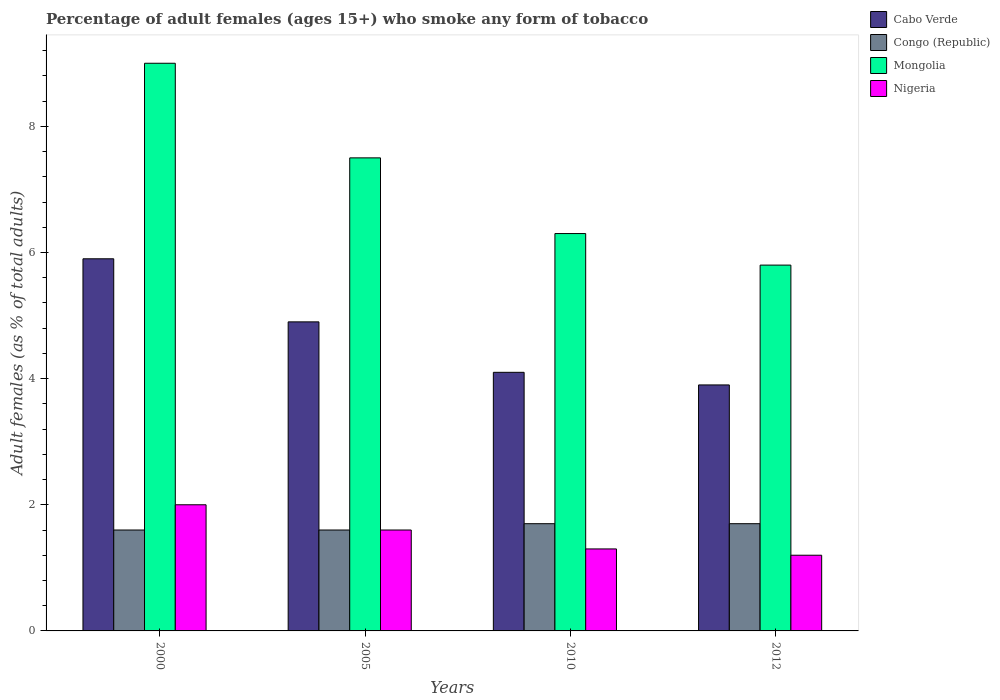How many different coloured bars are there?
Your answer should be very brief. 4. Are the number of bars per tick equal to the number of legend labels?
Your answer should be very brief. Yes. Are the number of bars on each tick of the X-axis equal?
Give a very brief answer. Yes. How many bars are there on the 4th tick from the right?
Offer a very short reply. 4. In how many cases, is the number of bars for a given year not equal to the number of legend labels?
Give a very brief answer. 0. Across all years, what is the maximum percentage of adult females who smoke in Cabo Verde?
Your answer should be very brief. 5.9. In which year was the percentage of adult females who smoke in Cabo Verde maximum?
Offer a very short reply. 2000. In which year was the percentage of adult females who smoke in Mongolia minimum?
Keep it short and to the point. 2012. What is the total percentage of adult females who smoke in Cabo Verde in the graph?
Give a very brief answer. 18.8. What is the difference between the percentage of adult females who smoke in Nigeria in 2005 and that in 2012?
Your response must be concise. 0.4. What is the difference between the percentage of adult females who smoke in Nigeria in 2005 and the percentage of adult females who smoke in Congo (Republic) in 2012?
Your answer should be compact. -0.1. What is the average percentage of adult females who smoke in Mongolia per year?
Ensure brevity in your answer.  7.15. In the year 2005, what is the difference between the percentage of adult females who smoke in Cabo Verde and percentage of adult females who smoke in Congo (Republic)?
Your answer should be compact. 3.3. In how many years, is the percentage of adult females who smoke in Nigeria greater than 4.4 %?
Give a very brief answer. 0. What is the ratio of the percentage of adult females who smoke in Cabo Verde in 2000 to that in 2012?
Offer a very short reply. 1.51. Is the difference between the percentage of adult females who smoke in Cabo Verde in 2000 and 2010 greater than the difference between the percentage of adult females who smoke in Congo (Republic) in 2000 and 2010?
Your answer should be compact. Yes. What is the difference between the highest and the second highest percentage of adult females who smoke in Nigeria?
Offer a very short reply. 0.4. In how many years, is the percentage of adult females who smoke in Nigeria greater than the average percentage of adult females who smoke in Nigeria taken over all years?
Provide a succinct answer. 2. Is the sum of the percentage of adult females who smoke in Cabo Verde in 2010 and 2012 greater than the maximum percentage of adult females who smoke in Congo (Republic) across all years?
Offer a terse response. Yes. Is it the case that in every year, the sum of the percentage of adult females who smoke in Nigeria and percentage of adult females who smoke in Mongolia is greater than the sum of percentage of adult females who smoke in Cabo Verde and percentage of adult females who smoke in Congo (Republic)?
Offer a very short reply. Yes. What does the 1st bar from the left in 2005 represents?
Make the answer very short. Cabo Verde. What does the 1st bar from the right in 2000 represents?
Ensure brevity in your answer.  Nigeria. Is it the case that in every year, the sum of the percentage of adult females who smoke in Cabo Verde and percentage of adult females who smoke in Nigeria is greater than the percentage of adult females who smoke in Congo (Republic)?
Ensure brevity in your answer.  Yes. Are all the bars in the graph horizontal?
Make the answer very short. No. What is the difference between two consecutive major ticks on the Y-axis?
Ensure brevity in your answer.  2. Are the values on the major ticks of Y-axis written in scientific E-notation?
Make the answer very short. No. Does the graph contain any zero values?
Your answer should be compact. No. Does the graph contain grids?
Offer a terse response. No. How are the legend labels stacked?
Offer a very short reply. Vertical. What is the title of the graph?
Ensure brevity in your answer.  Percentage of adult females (ages 15+) who smoke any form of tobacco. What is the label or title of the Y-axis?
Provide a succinct answer. Adult females (as % of total adults). What is the Adult females (as % of total adults) of Congo (Republic) in 2000?
Make the answer very short. 1.6. What is the Adult females (as % of total adults) in Mongolia in 2000?
Offer a very short reply. 9. What is the Adult females (as % of total adults) in Nigeria in 2000?
Offer a very short reply. 2. What is the Adult females (as % of total adults) in Mongolia in 2005?
Your answer should be compact. 7.5. What is the Adult females (as % of total adults) of Mongolia in 2010?
Offer a terse response. 6.3. What is the Adult females (as % of total adults) in Cabo Verde in 2012?
Provide a short and direct response. 3.9. What is the Adult females (as % of total adults) in Mongolia in 2012?
Offer a very short reply. 5.8. Across all years, what is the maximum Adult females (as % of total adults) in Congo (Republic)?
Keep it short and to the point. 1.7. Across all years, what is the maximum Adult females (as % of total adults) in Nigeria?
Provide a succinct answer. 2. Across all years, what is the minimum Adult females (as % of total adults) of Cabo Verde?
Make the answer very short. 3.9. Across all years, what is the minimum Adult females (as % of total adults) in Mongolia?
Your answer should be compact. 5.8. What is the total Adult females (as % of total adults) in Mongolia in the graph?
Your answer should be compact. 28.6. What is the total Adult females (as % of total adults) of Nigeria in the graph?
Provide a short and direct response. 6.1. What is the difference between the Adult females (as % of total adults) of Cabo Verde in 2000 and that in 2005?
Make the answer very short. 1. What is the difference between the Adult females (as % of total adults) of Congo (Republic) in 2000 and that in 2005?
Your answer should be compact. 0. What is the difference between the Adult females (as % of total adults) in Cabo Verde in 2000 and that in 2010?
Give a very brief answer. 1.8. What is the difference between the Adult females (as % of total adults) of Congo (Republic) in 2000 and that in 2010?
Ensure brevity in your answer.  -0.1. What is the difference between the Adult females (as % of total adults) of Mongolia in 2000 and that in 2010?
Provide a succinct answer. 2.7. What is the difference between the Adult females (as % of total adults) in Nigeria in 2000 and that in 2010?
Offer a terse response. 0.7. What is the difference between the Adult females (as % of total adults) in Congo (Republic) in 2000 and that in 2012?
Offer a very short reply. -0.1. What is the difference between the Adult females (as % of total adults) of Nigeria in 2000 and that in 2012?
Keep it short and to the point. 0.8. What is the difference between the Adult females (as % of total adults) of Cabo Verde in 2005 and that in 2010?
Give a very brief answer. 0.8. What is the difference between the Adult females (as % of total adults) in Nigeria in 2005 and that in 2010?
Provide a succinct answer. 0.3. What is the difference between the Adult females (as % of total adults) of Cabo Verde in 2005 and that in 2012?
Offer a very short reply. 1. What is the difference between the Adult females (as % of total adults) in Cabo Verde in 2010 and that in 2012?
Offer a very short reply. 0.2. What is the difference between the Adult females (as % of total adults) in Congo (Republic) in 2010 and that in 2012?
Ensure brevity in your answer.  0. What is the difference between the Adult females (as % of total adults) in Cabo Verde in 2000 and the Adult females (as % of total adults) in Congo (Republic) in 2005?
Offer a terse response. 4.3. What is the difference between the Adult females (as % of total adults) in Cabo Verde in 2000 and the Adult females (as % of total adults) in Nigeria in 2005?
Provide a succinct answer. 4.3. What is the difference between the Adult females (as % of total adults) of Congo (Republic) in 2000 and the Adult females (as % of total adults) of Mongolia in 2005?
Provide a short and direct response. -5.9. What is the difference between the Adult females (as % of total adults) in Mongolia in 2000 and the Adult females (as % of total adults) in Nigeria in 2005?
Your answer should be very brief. 7.4. What is the difference between the Adult females (as % of total adults) in Cabo Verde in 2000 and the Adult females (as % of total adults) in Congo (Republic) in 2010?
Keep it short and to the point. 4.2. What is the difference between the Adult females (as % of total adults) of Congo (Republic) in 2000 and the Adult females (as % of total adults) of Mongolia in 2010?
Keep it short and to the point. -4.7. What is the difference between the Adult females (as % of total adults) of Cabo Verde in 2000 and the Adult females (as % of total adults) of Nigeria in 2012?
Provide a succinct answer. 4.7. What is the difference between the Adult females (as % of total adults) in Mongolia in 2000 and the Adult females (as % of total adults) in Nigeria in 2012?
Give a very brief answer. 7.8. What is the difference between the Adult females (as % of total adults) in Cabo Verde in 2005 and the Adult females (as % of total adults) in Nigeria in 2010?
Your answer should be compact. 3.6. What is the difference between the Adult females (as % of total adults) in Mongolia in 2005 and the Adult females (as % of total adults) in Nigeria in 2010?
Give a very brief answer. 6.2. What is the difference between the Adult females (as % of total adults) in Cabo Verde in 2005 and the Adult females (as % of total adults) in Congo (Republic) in 2012?
Keep it short and to the point. 3.2. What is the difference between the Adult females (as % of total adults) of Cabo Verde in 2005 and the Adult females (as % of total adults) of Nigeria in 2012?
Keep it short and to the point. 3.7. What is the difference between the Adult females (as % of total adults) in Congo (Republic) in 2005 and the Adult females (as % of total adults) in Mongolia in 2012?
Offer a terse response. -4.2. What is the difference between the Adult females (as % of total adults) of Mongolia in 2005 and the Adult females (as % of total adults) of Nigeria in 2012?
Offer a terse response. 6.3. What is the difference between the Adult females (as % of total adults) of Cabo Verde in 2010 and the Adult females (as % of total adults) of Congo (Republic) in 2012?
Offer a very short reply. 2.4. What is the difference between the Adult females (as % of total adults) in Cabo Verde in 2010 and the Adult females (as % of total adults) in Mongolia in 2012?
Offer a very short reply. -1.7. What is the difference between the Adult females (as % of total adults) in Cabo Verde in 2010 and the Adult females (as % of total adults) in Nigeria in 2012?
Your answer should be compact. 2.9. What is the difference between the Adult females (as % of total adults) of Congo (Republic) in 2010 and the Adult females (as % of total adults) of Mongolia in 2012?
Offer a very short reply. -4.1. What is the average Adult females (as % of total adults) of Congo (Republic) per year?
Ensure brevity in your answer.  1.65. What is the average Adult females (as % of total adults) of Mongolia per year?
Provide a succinct answer. 7.15. What is the average Adult females (as % of total adults) of Nigeria per year?
Give a very brief answer. 1.52. In the year 2000, what is the difference between the Adult females (as % of total adults) in Cabo Verde and Adult females (as % of total adults) in Nigeria?
Make the answer very short. 3.9. In the year 2000, what is the difference between the Adult females (as % of total adults) in Congo (Republic) and Adult females (as % of total adults) in Mongolia?
Keep it short and to the point. -7.4. In the year 2000, what is the difference between the Adult females (as % of total adults) of Mongolia and Adult females (as % of total adults) of Nigeria?
Offer a terse response. 7. In the year 2005, what is the difference between the Adult females (as % of total adults) of Cabo Verde and Adult females (as % of total adults) of Congo (Republic)?
Provide a succinct answer. 3.3. In the year 2005, what is the difference between the Adult females (as % of total adults) of Cabo Verde and Adult females (as % of total adults) of Nigeria?
Make the answer very short. 3.3. In the year 2005, what is the difference between the Adult females (as % of total adults) in Mongolia and Adult females (as % of total adults) in Nigeria?
Your response must be concise. 5.9. In the year 2010, what is the difference between the Adult females (as % of total adults) in Cabo Verde and Adult females (as % of total adults) in Congo (Republic)?
Ensure brevity in your answer.  2.4. In the year 2010, what is the difference between the Adult females (as % of total adults) in Cabo Verde and Adult females (as % of total adults) in Mongolia?
Offer a terse response. -2.2. In the year 2010, what is the difference between the Adult females (as % of total adults) in Congo (Republic) and Adult females (as % of total adults) in Mongolia?
Your answer should be very brief. -4.6. In the year 2010, what is the difference between the Adult females (as % of total adults) in Mongolia and Adult females (as % of total adults) in Nigeria?
Provide a short and direct response. 5. In the year 2012, what is the difference between the Adult females (as % of total adults) in Cabo Verde and Adult females (as % of total adults) in Congo (Republic)?
Offer a very short reply. 2.2. What is the ratio of the Adult females (as % of total adults) in Cabo Verde in 2000 to that in 2005?
Your answer should be compact. 1.2. What is the ratio of the Adult females (as % of total adults) in Cabo Verde in 2000 to that in 2010?
Give a very brief answer. 1.44. What is the ratio of the Adult females (as % of total adults) in Mongolia in 2000 to that in 2010?
Provide a succinct answer. 1.43. What is the ratio of the Adult females (as % of total adults) of Nigeria in 2000 to that in 2010?
Your answer should be very brief. 1.54. What is the ratio of the Adult females (as % of total adults) of Cabo Verde in 2000 to that in 2012?
Your answer should be compact. 1.51. What is the ratio of the Adult females (as % of total adults) of Mongolia in 2000 to that in 2012?
Offer a very short reply. 1.55. What is the ratio of the Adult females (as % of total adults) in Nigeria in 2000 to that in 2012?
Your answer should be compact. 1.67. What is the ratio of the Adult females (as % of total adults) in Cabo Verde in 2005 to that in 2010?
Offer a very short reply. 1.2. What is the ratio of the Adult females (as % of total adults) in Congo (Republic) in 2005 to that in 2010?
Keep it short and to the point. 0.94. What is the ratio of the Adult females (as % of total adults) in Mongolia in 2005 to that in 2010?
Keep it short and to the point. 1.19. What is the ratio of the Adult females (as % of total adults) of Nigeria in 2005 to that in 2010?
Offer a terse response. 1.23. What is the ratio of the Adult females (as % of total adults) in Cabo Verde in 2005 to that in 2012?
Your answer should be compact. 1.26. What is the ratio of the Adult females (as % of total adults) in Congo (Republic) in 2005 to that in 2012?
Your answer should be compact. 0.94. What is the ratio of the Adult females (as % of total adults) of Mongolia in 2005 to that in 2012?
Your answer should be compact. 1.29. What is the ratio of the Adult females (as % of total adults) in Cabo Verde in 2010 to that in 2012?
Ensure brevity in your answer.  1.05. What is the ratio of the Adult females (as % of total adults) of Mongolia in 2010 to that in 2012?
Give a very brief answer. 1.09. What is the difference between the highest and the second highest Adult females (as % of total adults) in Mongolia?
Offer a terse response. 1.5. What is the difference between the highest and the second highest Adult females (as % of total adults) in Nigeria?
Your answer should be very brief. 0.4. What is the difference between the highest and the lowest Adult females (as % of total adults) in Congo (Republic)?
Offer a terse response. 0.1. 